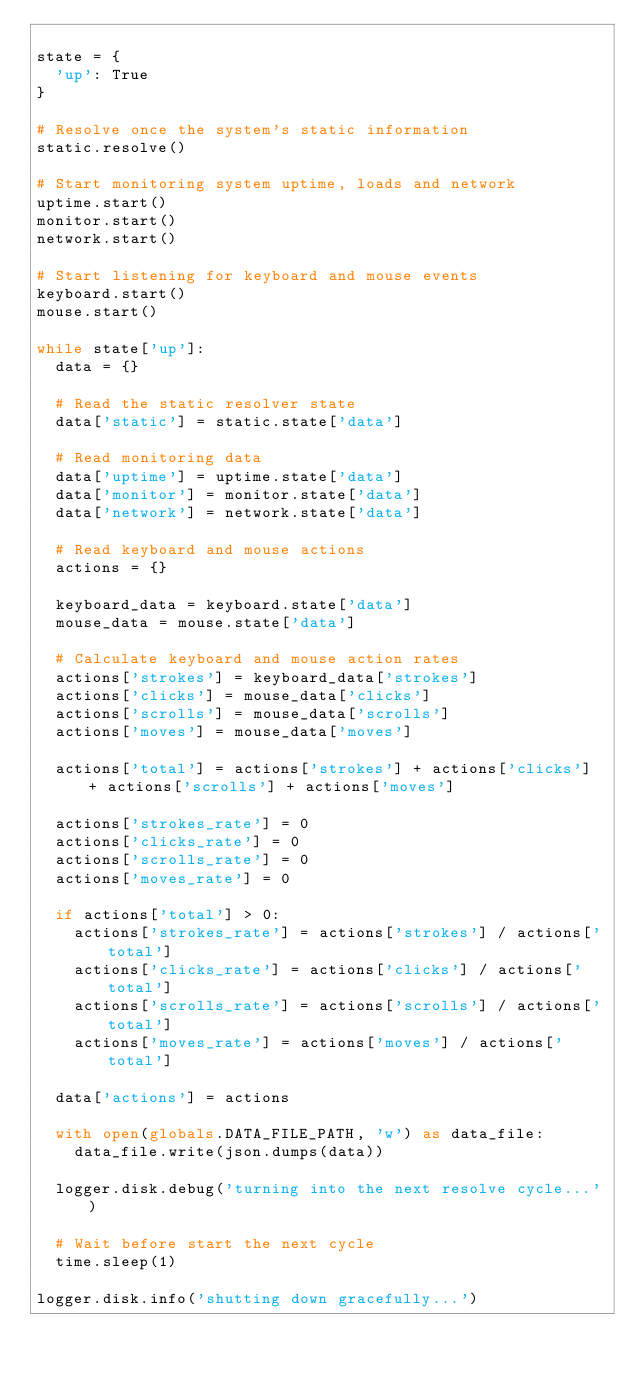Convert code to text. <code><loc_0><loc_0><loc_500><loc_500><_Python_>
state = {
  'up': True
}

# Resolve once the system's static information
static.resolve()

# Start monitoring system uptime, loads and network
uptime.start()
monitor.start()
network.start()

# Start listening for keyboard and mouse events
keyboard.start()
mouse.start()

while state['up']:
  data = {}

  # Read the static resolver state
  data['static'] = static.state['data']

  # Read monitoring data
  data['uptime'] = uptime.state['data']
  data['monitor'] = monitor.state['data']
  data['network'] = network.state['data']

  # Read keyboard and mouse actions
  actions = {}

  keyboard_data = keyboard.state['data']
  mouse_data = mouse.state['data']

  # Calculate keyboard and mouse action rates
  actions['strokes'] = keyboard_data['strokes']
  actions['clicks'] = mouse_data['clicks']
  actions['scrolls'] = mouse_data['scrolls']
  actions['moves'] = mouse_data['moves']

  actions['total'] = actions['strokes'] + actions['clicks'] + actions['scrolls'] + actions['moves']

  actions['strokes_rate'] = 0
  actions['clicks_rate'] = 0
  actions['scrolls_rate'] = 0
  actions['moves_rate'] = 0

  if actions['total'] > 0:
    actions['strokes_rate'] = actions['strokes'] / actions['total']
    actions['clicks_rate'] = actions['clicks'] / actions['total']
    actions['scrolls_rate'] = actions['scrolls'] / actions['total']
    actions['moves_rate'] = actions['moves'] / actions['total']

  data['actions'] = actions

  with open(globals.DATA_FILE_PATH, 'w') as data_file:
    data_file.write(json.dumps(data))

  logger.disk.debug('turning into the next resolve cycle...')

  # Wait before start the next cycle
  time.sleep(1)

logger.disk.info('shutting down gracefully...')</code> 